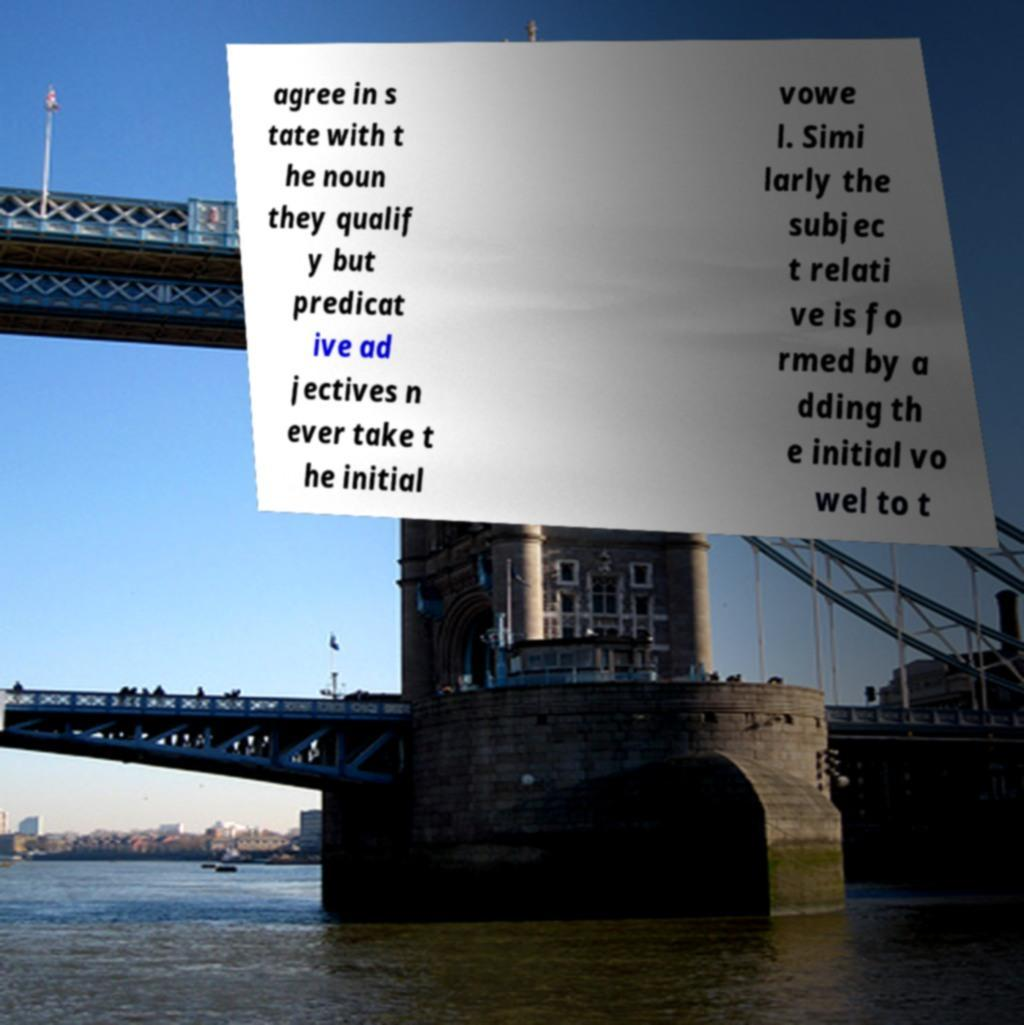I need the written content from this picture converted into text. Can you do that? agree in s tate with t he noun they qualif y but predicat ive ad jectives n ever take t he initial vowe l. Simi larly the subjec t relati ve is fo rmed by a dding th e initial vo wel to t 